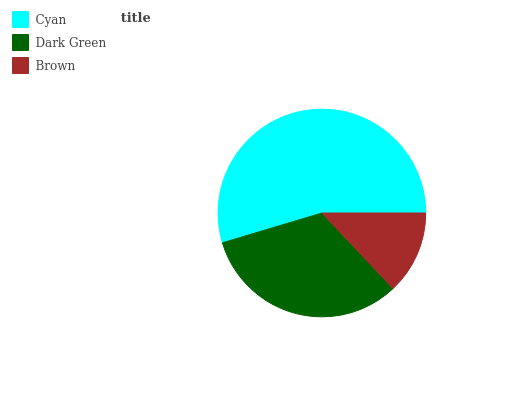Is Brown the minimum?
Answer yes or no. Yes. Is Cyan the maximum?
Answer yes or no. Yes. Is Dark Green the minimum?
Answer yes or no. No. Is Dark Green the maximum?
Answer yes or no. No. Is Cyan greater than Dark Green?
Answer yes or no. Yes. Is Dark Green less than Cyan?
Answer yes or no. Yes. Is Dark Green greater than Cyan?
Answer yes or no. No. Is Cyan less than Dark Green?
Answer yes or no. No. Is Dark Green the high median?
Answer yes or no. Yes. Is Dark Green the low median?
Answer yes or no. Yes. Is Cyan the high median?
Answer yes or no. No. Is Brown the low median?
Answer yes or no. No. 